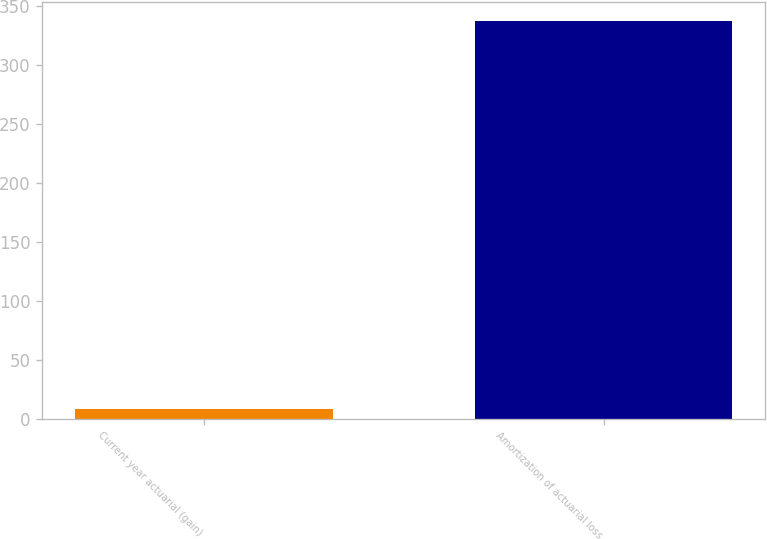Convert chart. <chart><loc_0><loc_0><loc_500><loc_500><bar_chart><fcel>Current year actuarial (gain)<fcel>Amortization of actuarial loss<nl><fcel>8<fcel>337<nl></chart> 